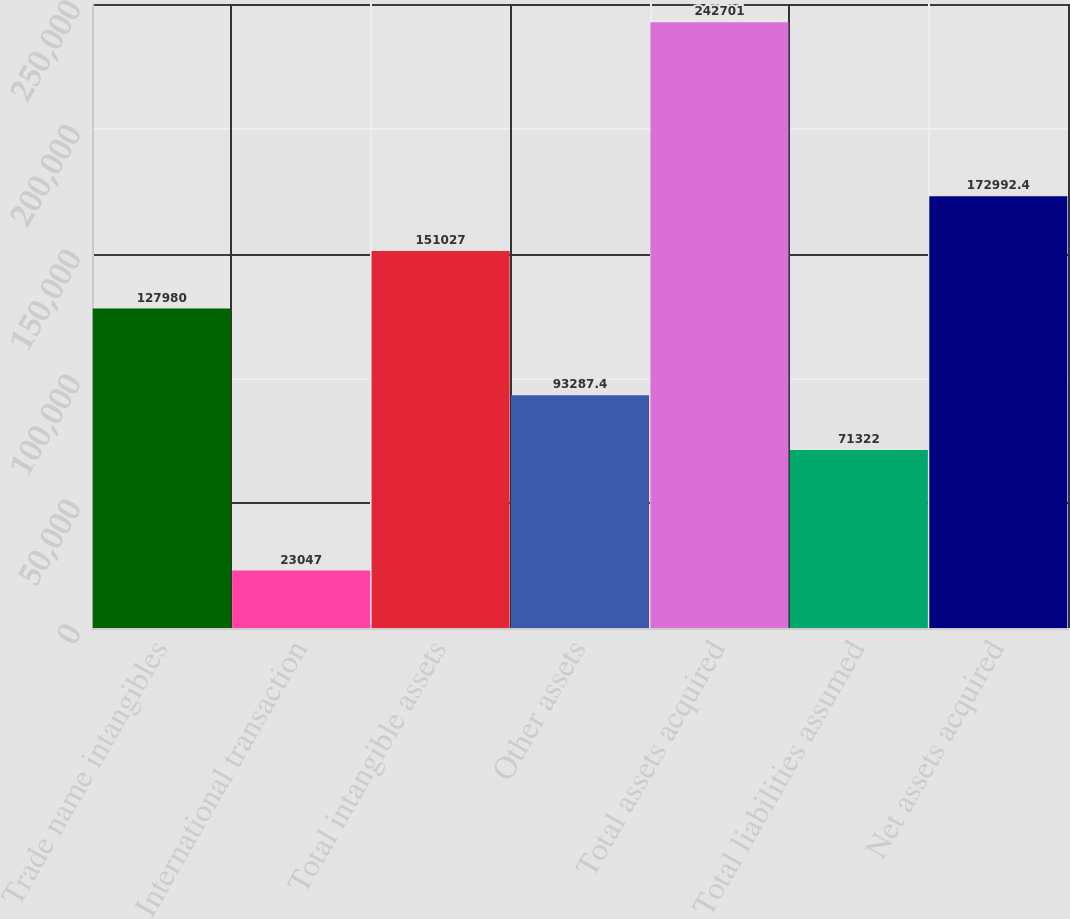Convert chart to OTSL. <chart><loc_0><loc_0><loc_500><loc_500><bar_chart><fcel>Trade name intangibles<fcel>International transaction<fcel>Total intangible assets<fcel>Other assets<fcel>Total assets acquired<fcel>Total liabilities assumed<fcel>Net assets acquired<nl><fcel>127980<fcel>23047<fcel>151027<fcel>93287.4<fcel>242701<fcel>71322<fcel>172992<nl></chart> 